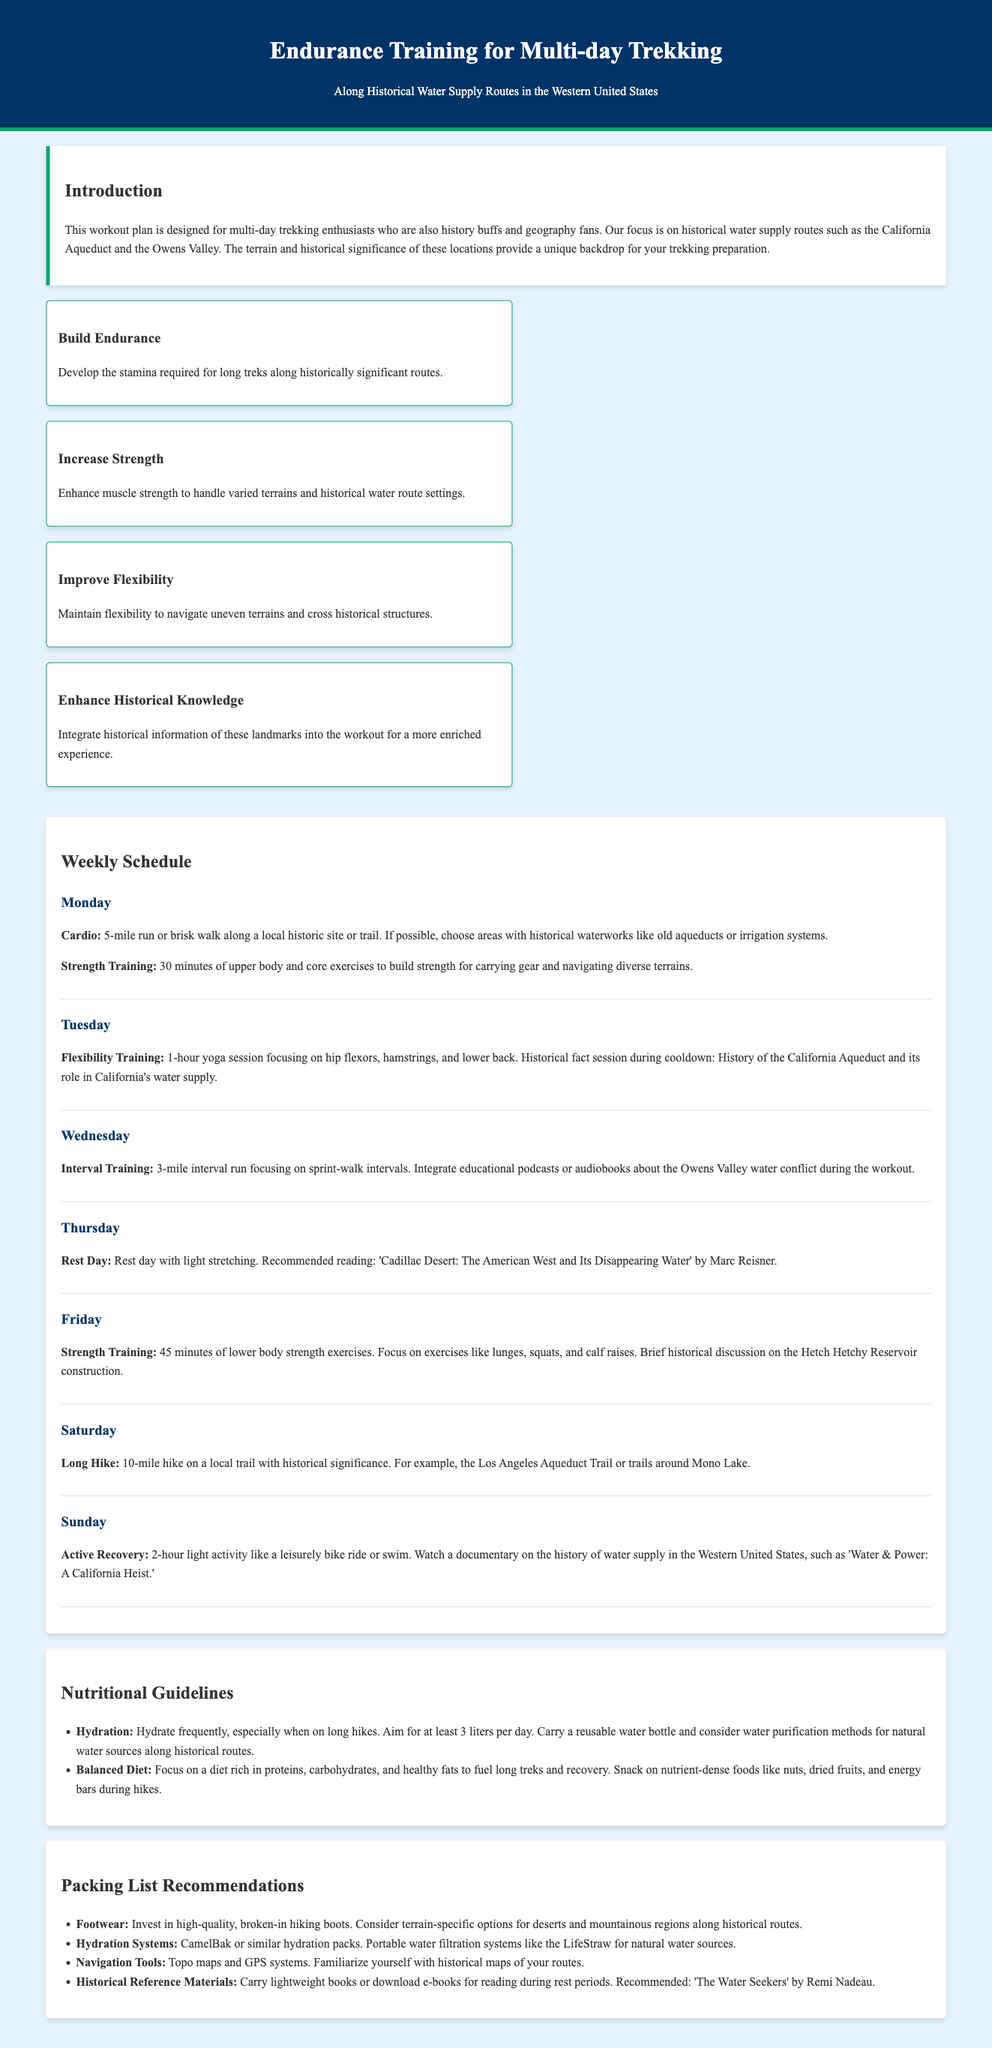What is the title of the workout plan? The title of the workout plan is stated at the top of the document.
Answer: Endurance Training for Multi-day Trekking What is the goal of Tuesday's workout? The goal of Tuesday's workout is detailed in the Weekly Schedule section.
Answer: Flexibility Training How long should the long hike on Saturday be? The specific distance of the hike is mentioned in the Saturday section of the Weekly Schedule.
Answer: 10-mile What book is recommended for reading on Thursday? The recommended reading is given in the context of a rest day.
Answer: Cadillac Desert: The American West and Its Disappearing Water What is one of the hydration recommendations mentioned? The specific hydration recommendation is found in the Nutritional Guidelines section.
Answer: Hydrate frequently, especially when on long hikes What is the focus of strength training on Wednesday? The focus for Wednesday's strength training can be inferred from the Weekly Schedule.
Answer: Lower body strength exercises Which historical site is suggested for the Monday run? The specific type of location is mentioned in the description of the exercise for Monday.
Answer: Local historic site or trail What type of training is incorporated during the cooldown on Tuesday? This is stated in the Tuesday section of the Weekly Schedule.
Answer: Historical fact session What is the purpose of the “Enhance Historical Knowledge” objective? This objective is outlined among the section that details workout goals.
Answer: Integrate historical information of these landmarks into the workout 